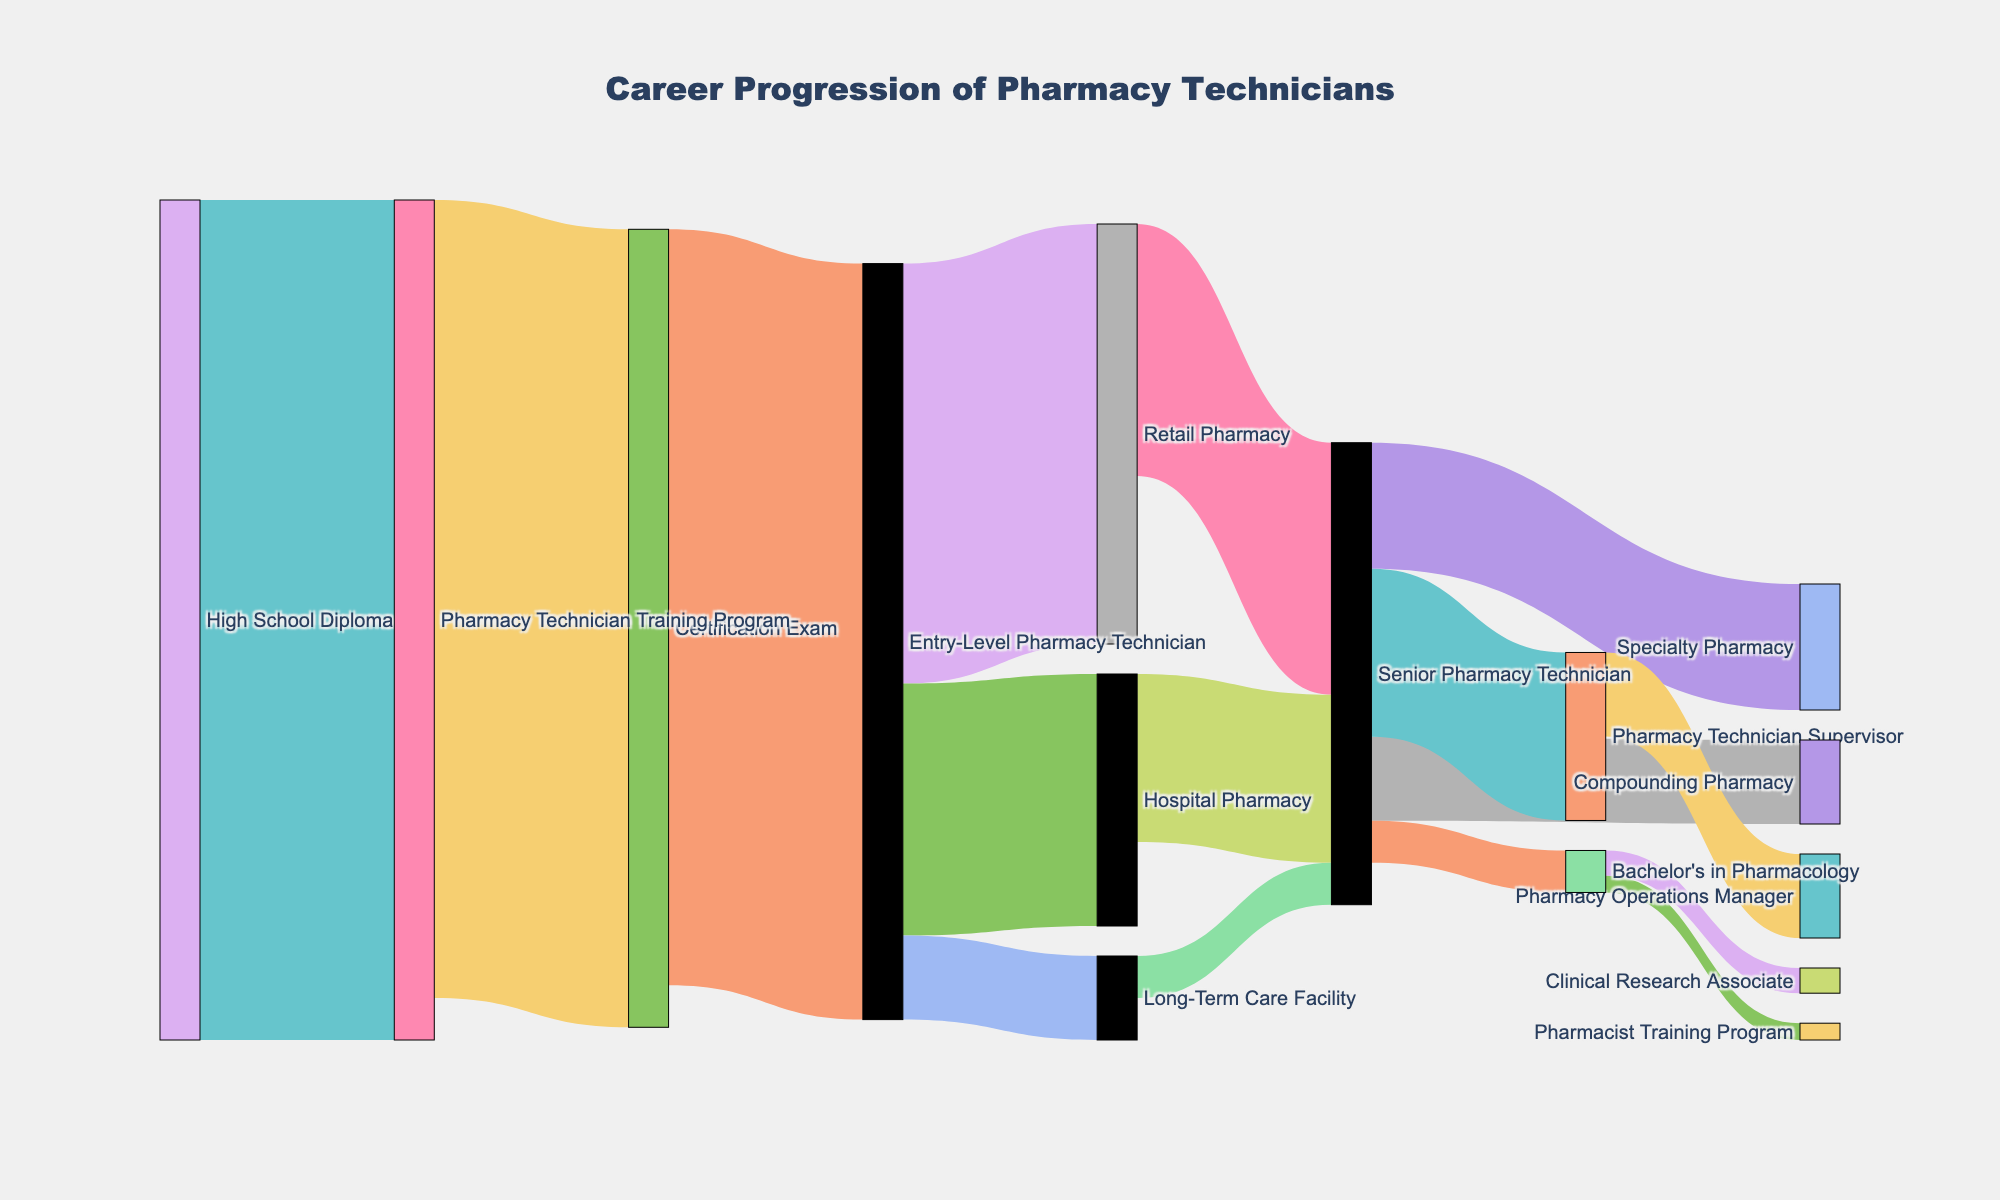What is the title of the figure? The title of the figure is displayed at the top, which is "Career Progression of Pharmacy Technicians".
Answer: Career Progression of Pharmacy Technicians Which has more individuals transitioning to a Senior Pharmacy Technician: the Retail Pharmacy or the Hospital Pharmacy? To determine this, you need to compare the values for the transitions from Retail Pharmacy to Senior Pharmacy Technician and from Hospital Pharmacy to Senior Pharmacy Technician. The Retail Pharmacy transition has a value of 30, while the Hospital Pharmacy transition has a value of 20.
Answer: Retail Pharmacy Can you identify the two possible career paths after becoming a Senior Pharmacy Technician? By looking at the branches stemming from "Senior Pharmacy Technician", you will notice three distinct paths: Specialty Pharmacy, Compounding Pharmacy, and Pharmacy Technician Supervisor, with values 15, 10, and 20 respectively.
Answer: Specialty Pharmacy, Compounding Pharmacy, and Pharmacy Technician Supervisor How many individuals transitioned from an Entry-Level Pharmacy Technician to a Long-Term Care Facility? Check the flow from Entry-Level Pharmacy Technician to Long-Term Care Facility, which displays a value of 10.
Answer: 10 Which is the more common next step after obtaining a Pharmacy Technician Training Program: Certification Exam or something else? To determine this, observe the flow values from Pharmacy Technician Training Program. The flow to Certification Exam has a value of 95, which is the highest value coming out of Pharmacy Technician Training Program.
Answer: Certification Exam Is becoming a Pharmacy Operations Manager more common than pursuing a Bachelor's degree after being a Pharmacy Technician Supervisor? Compare the values of transitions from Pharmacy Technician Supervisor to Pharmacy Operations Manager and to Bachelor's in Pharmacology, which are 10 and 5 respectively. Becoming a Pharmacy Operations Manager is more common.
Answer: Yes How many individuals start from High School Diploma and end up at Retail Pharmacy, accounting for intermediate transitions? We first see 100 individuals progressing from High School Diploma to Pharmacy Technician Training Program, followed by 95 to Certification Exam, 90 to Entry-Level Pharmacy Technician, and finally 50 to Retail Pharmacy. Therefore, the number is the same as that transitioning into Retail Pharmacy after accounting for intermediate steps.
Answer: 50 Which pathway has the lowest value: Entry-Level Pharmacy Technician to Retail Pharmacy, Entry-Level Pharmacy Technician to Hospital Pharmacy, or Entry-Level Pharmacy Technician to Long-Term Care Facility? Compare the values of the transitions: Retail Pharmacy (50), Hospital Pharmacy (30), and Long-Term Care Facility (10). The lowest is Long-Term Care Facility.
Answer: Long-Term Care Facility 